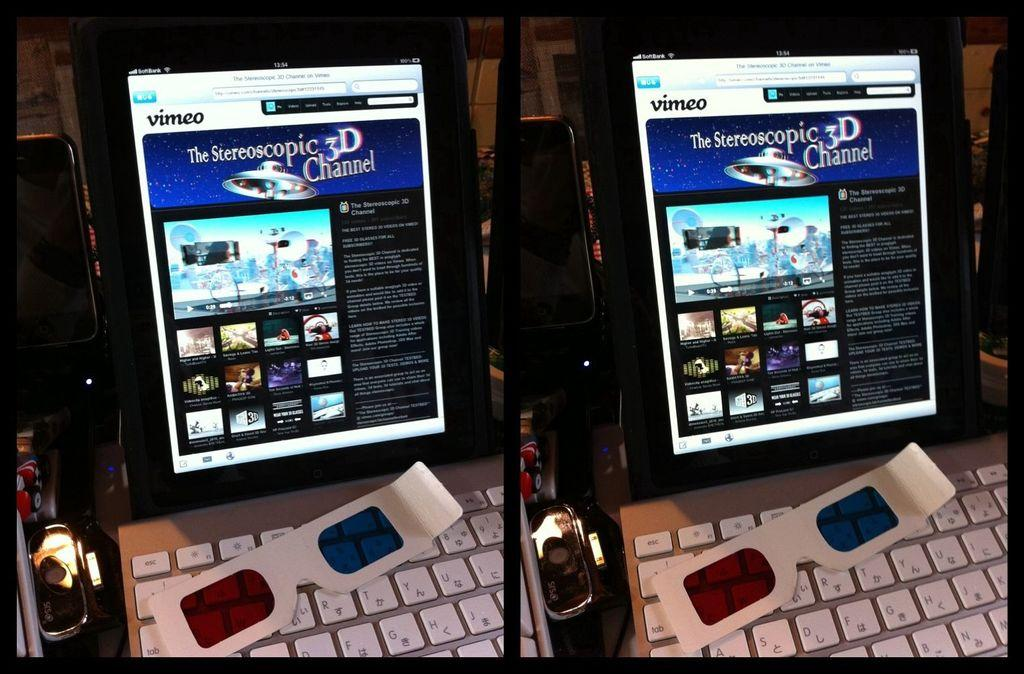Provide a one-sentence caption for the provided image. a 3D channel logo that is on the screen. 